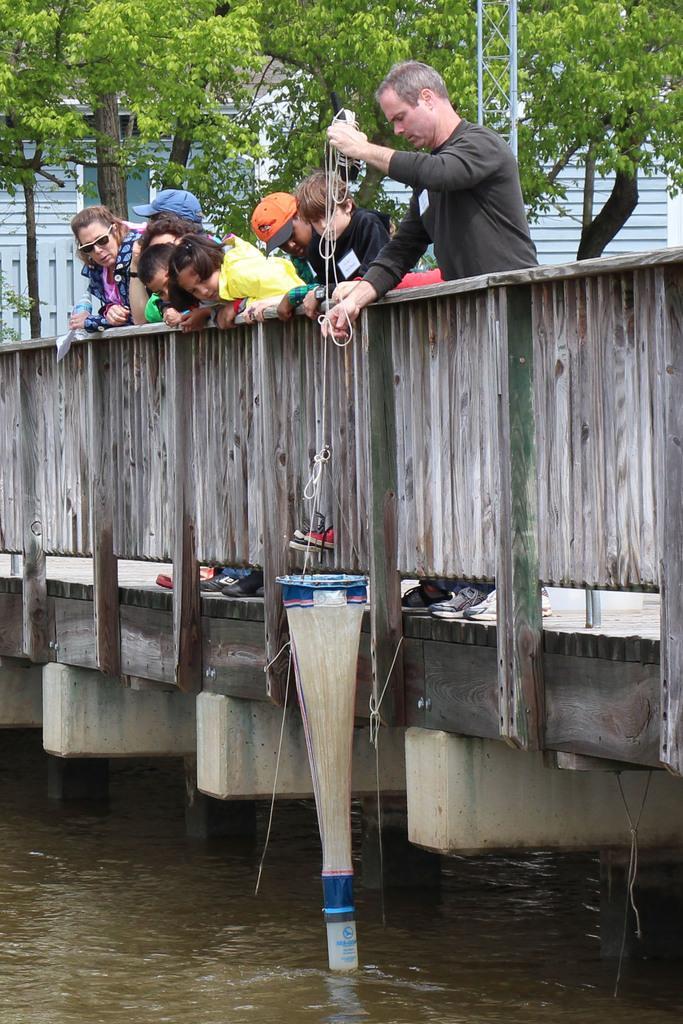How would you summarize this image in a sentence or two? In this image there is a lake, on above the lake there is a bridge, on that bridge few people are standing, one man is catching fishes with net, in the background there are trees. 